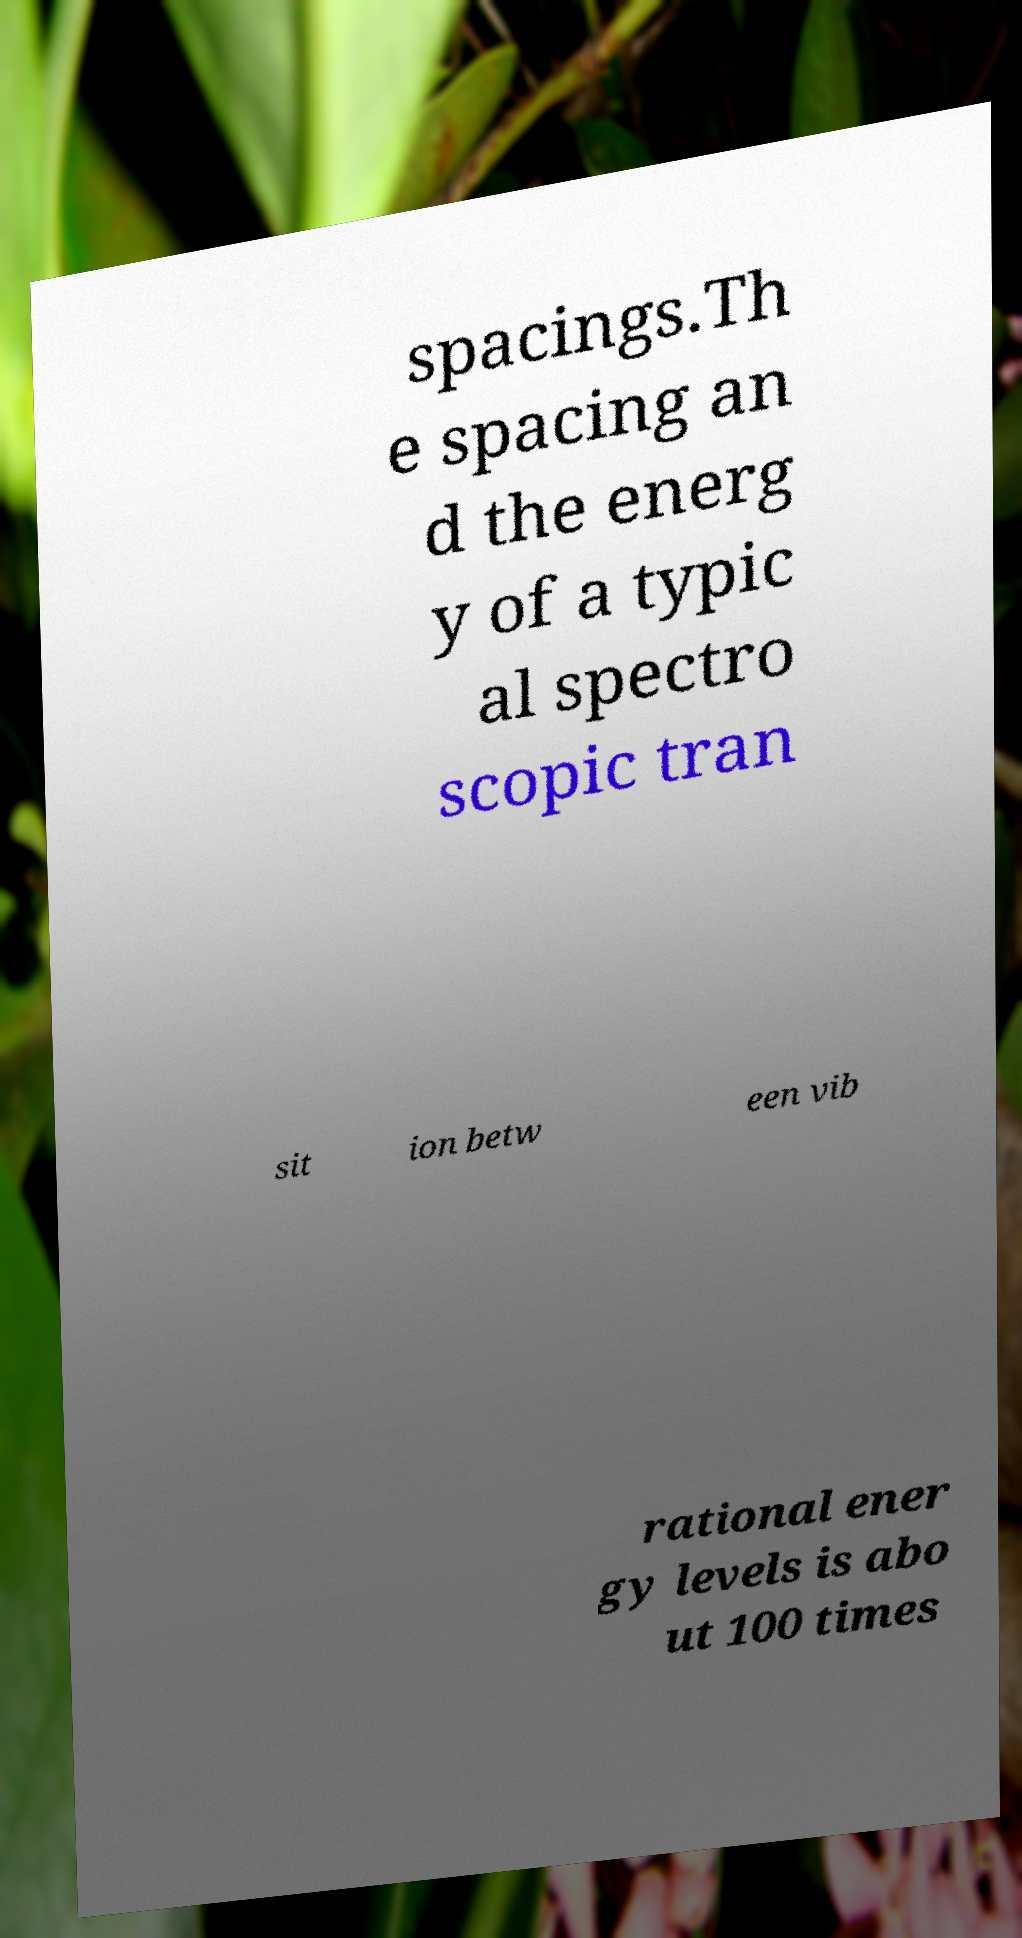I need the written content from this picture converted into text. Can you do that? spacings.Th e spacing an d the energ y of a typic al spectro scopic tran sit ion betw een vib rational ener gy levels is abo ut 100 times 